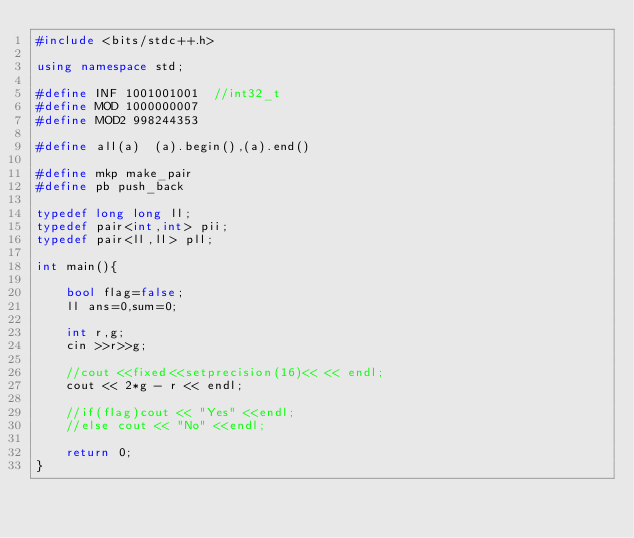<code> <loc_0><loc_0><loc_500><loc_500><_C++_>#include <bits/stdc++.h>

using namespace std;

#define INF 1001001001  //int32_t
#define MOD 1000000007
#define MOD2 998244353

#define all(a)  (a).begin(),(a).end()

#define mkp make_pair
#define pb push_back

typedef long long ll;
typedef pair<int,int> pii;
typedef pair<ll,ll> pll;

int main(){

    bool flag=false;
    ll ans=0,sum=0;

    int r,g;
    cin >>r>>g;

    //cout <<fixed<<setprecision(16)<< << endl;
    cout << 2*g - r << endl;

    //if(flag)cout << "Yes" <<endl;
    //else cout << "No" <<endl;
    
    return 0;
}
</code> 